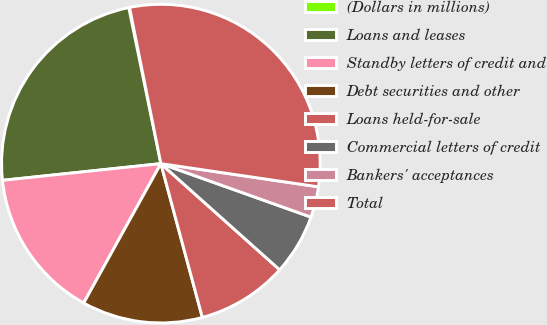Convert chart to OTSL. <chart><loc_0><loc_0><loc_500><loc_500><pie_chart><fcel>(Dollars in millions)<fcel>Loans and leases<fcel>Standby letters of credit and<fcel>Debt securities and other<fcel>Loans held-for-sale<fcel>Commercial letters of credit<fcel>Bankers' acceptances<fcel>Total<nl><fcel>0.08%<fcel>23.44%<fcel>15.28%<fcel>12.24%<fcel>9.2%<fcel>6.16%<fcel>3.12%<fcel>30.48%<nl></chart> 